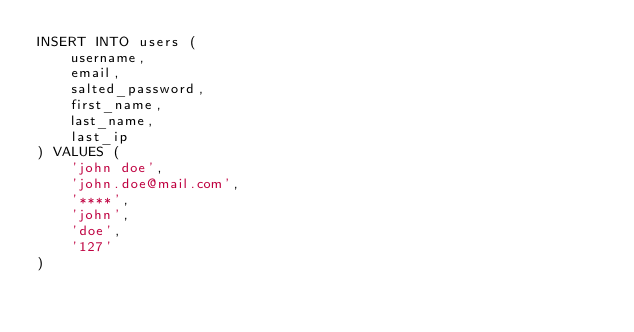<code> <loc_0><loc_0><loc_500><loc_500><_SQL_>INSERT INTO users (
	username,
	email,
	salted_password,
	first_name,
	last_name,
	last_ip
) VALUES (
	'john doe',
	'john.doe@mail.com',
	'****',
	'john',
	'doe',
	'127'
)</code> 